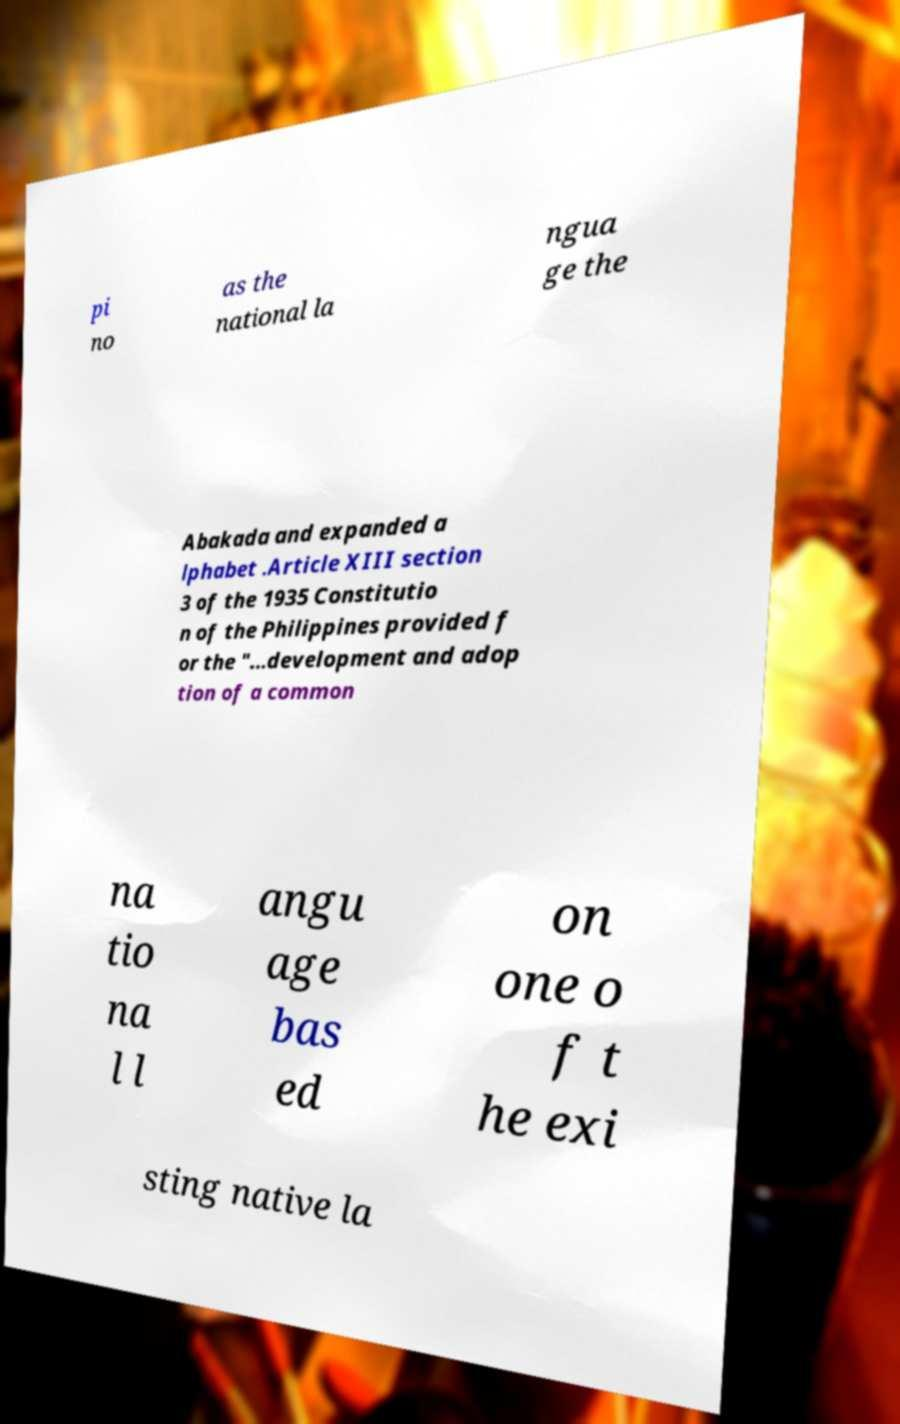For documentation purposes, I need the text within this image transcribed. Could you provide that? pi no as the national la ngua ge the Abakada and expanded a lphabet .Article XIII section 3 of the 1935 Constitutio n of the Philippines provided f or the "...development and adop tion of a common na tio na l l angu age bas ed on one o f t he exi sting native la 